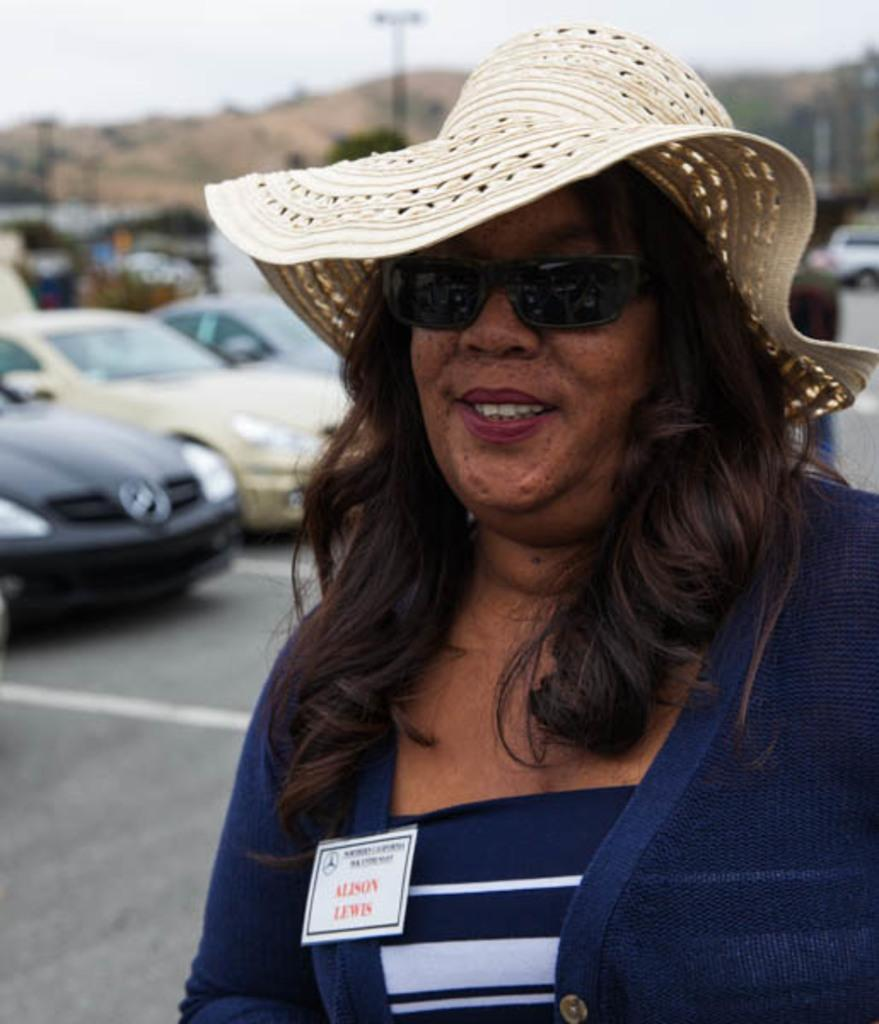Who is the main subject in the image? There is a lady in the image. Where is the lady located in the image? The lady is on the right side of the image. What accessories is the lady wearing? The lady is wearing glasses and a hat. What can be seen in the background of the image? There are cars in the background of the image. How many lizards are crawling on the lady's hat in the image? There are no lizards present in the image, and therefore none are crawling on the lady's hat. What type of woman is depicted in the image? The provided facts do not specify the type of woman; they only mention that the lady is wearing glasses and a hat. 